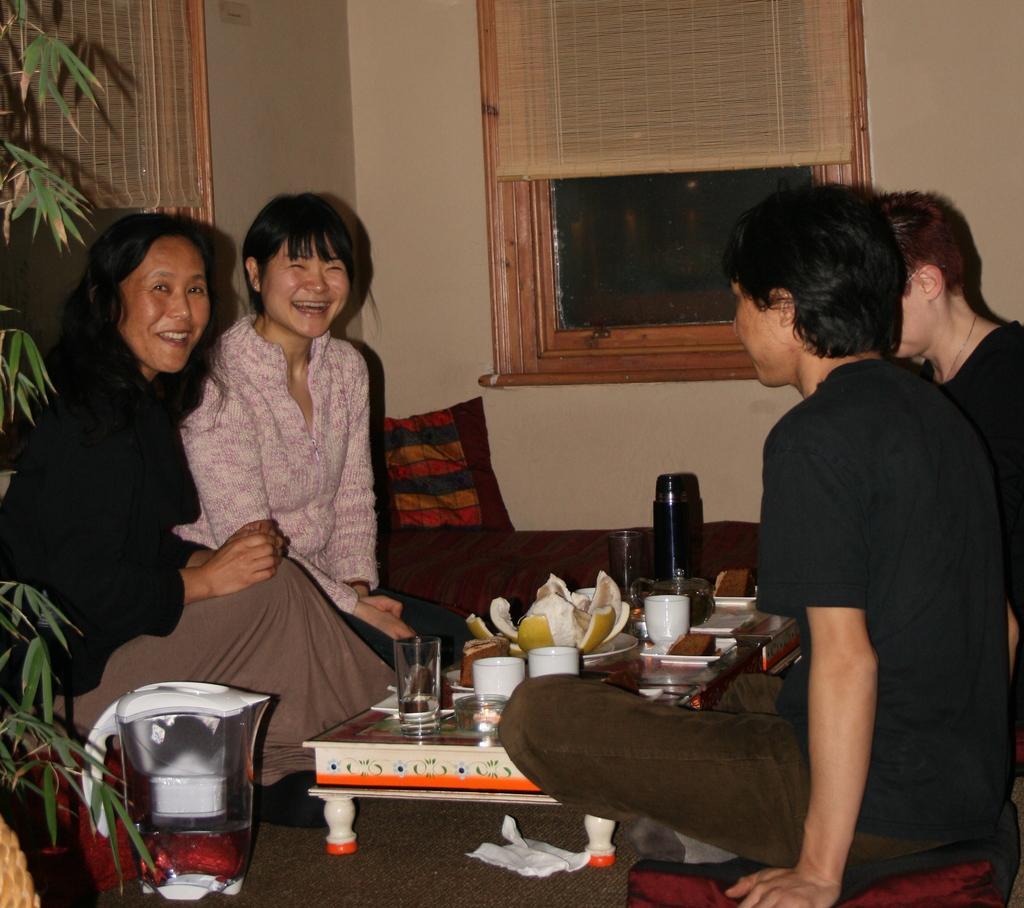Please provide a concise description of this image. The image is inside the room. In the image there are four people sitting on chair in front of a table, on table we can see a glass,fruit,plate,bottle. In background there is a window which is closed and curtain,wall which is in cream color and left side we can also see a plant with green leaves. 